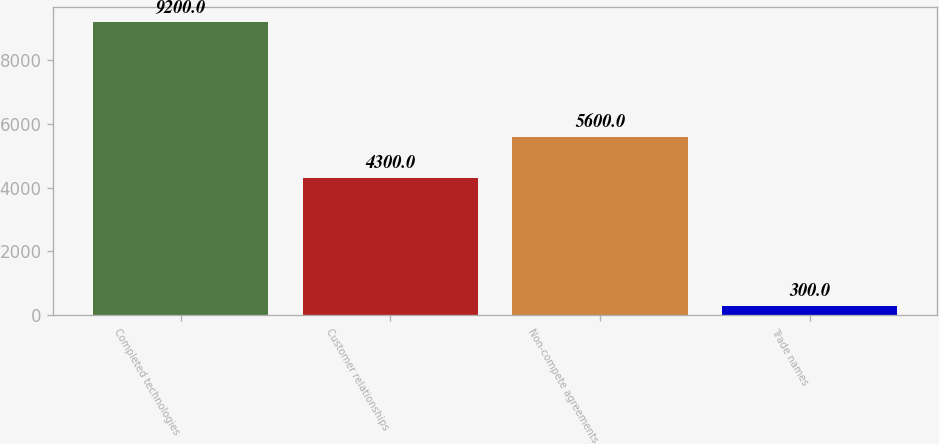<chart> <loc_0><loc_0><loc_500><loc_500><bar_chart><fcel>Completed technologies<fcel>Customer relationships<fcel>Non-compete agreements<fcel>Trade names<nl><fcel>9200<fcel>4300<fcel>5600<fcel>300<nl></chart> 